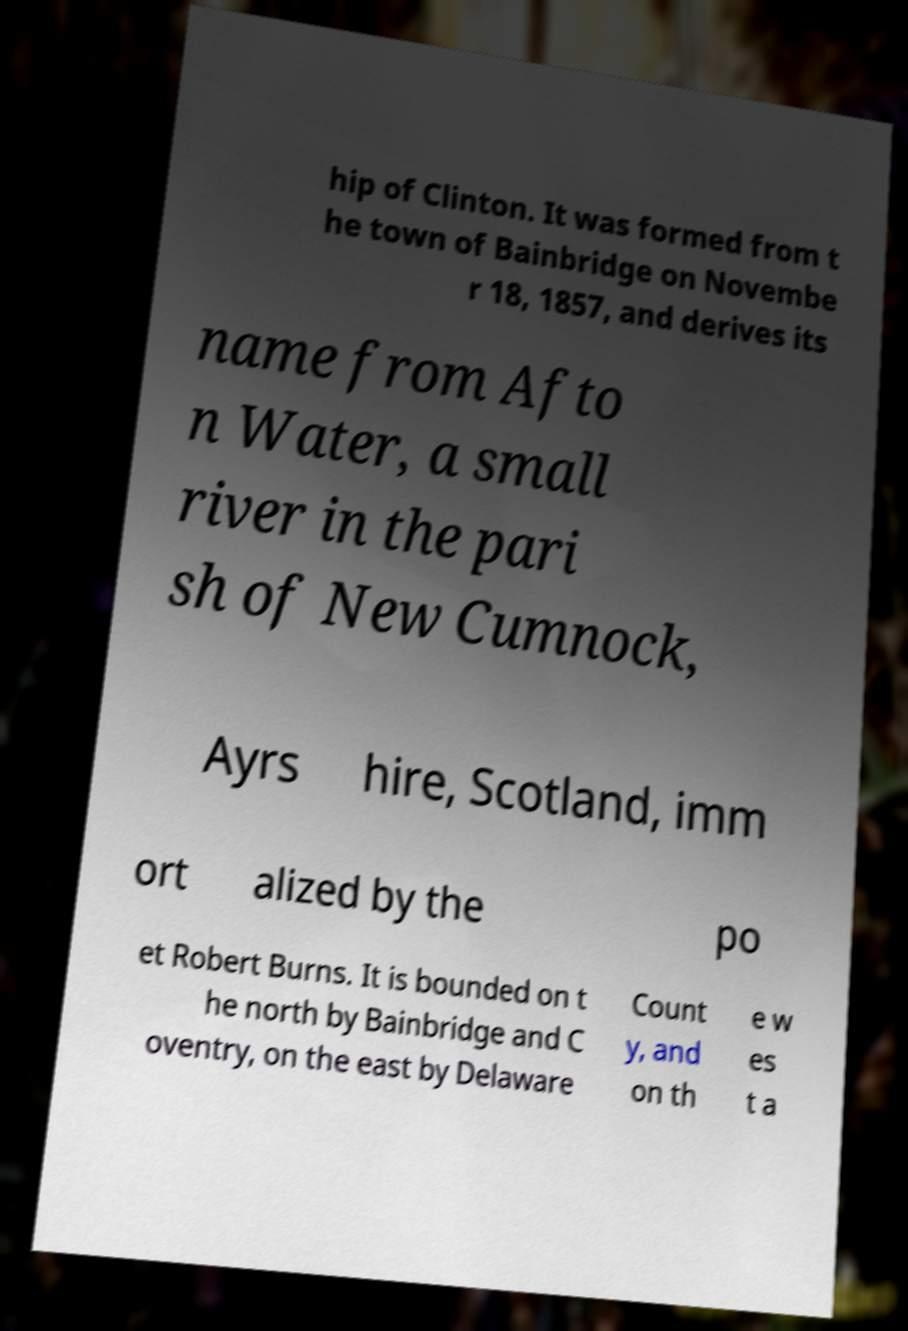Please identify and transcribe the text found in this image. hip of Clinton. It was formed from t he town of Bainbridge on Novembe r 18, 1857, and derives its name from Afto n Water, a small river in the pari sh of New Cumnock, Ayrs hire, Scotland, imm ort alized by the po et Robert Burns. It is bounded on t he north by Bainbridge and C oventry, on the east by Delaware Count y, and on th e w es t a 